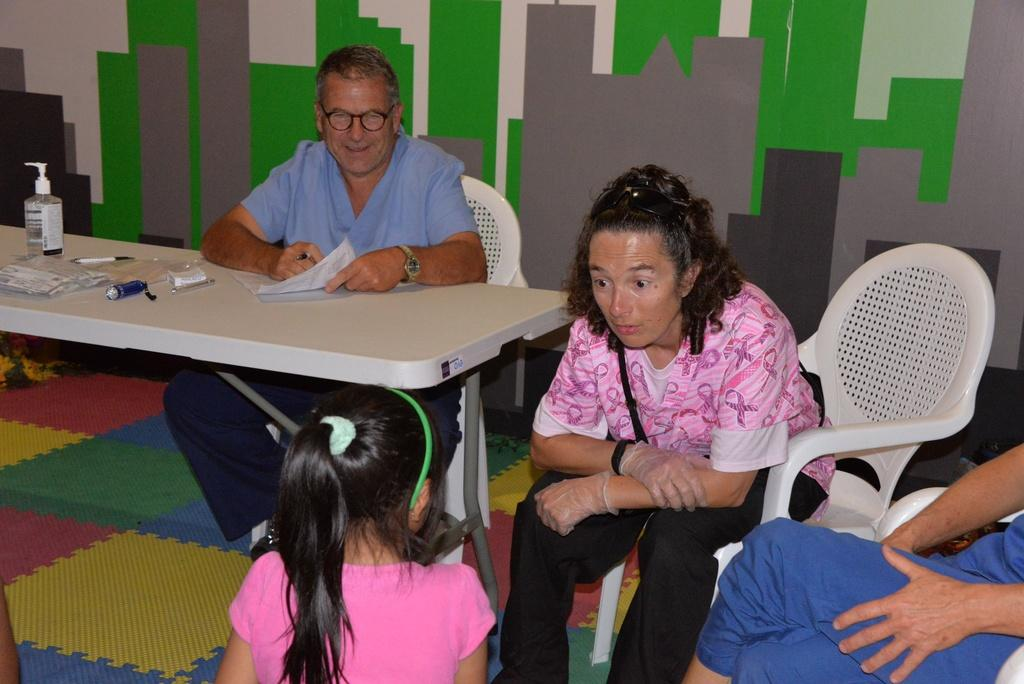How many people are sitting in the image? There are three persons sitting on chairs in the image. Can you describe the age group of one of the persons? Yes, there is a child in the image. What is the main piece of furniture in the image? There is a table in the image. What can be found on the table? There are items on the table. What type of list can be seen on the table in the image? There is no list present on the table in the image. What kind of ray is visible in the image? There is no ray visible in the image. 